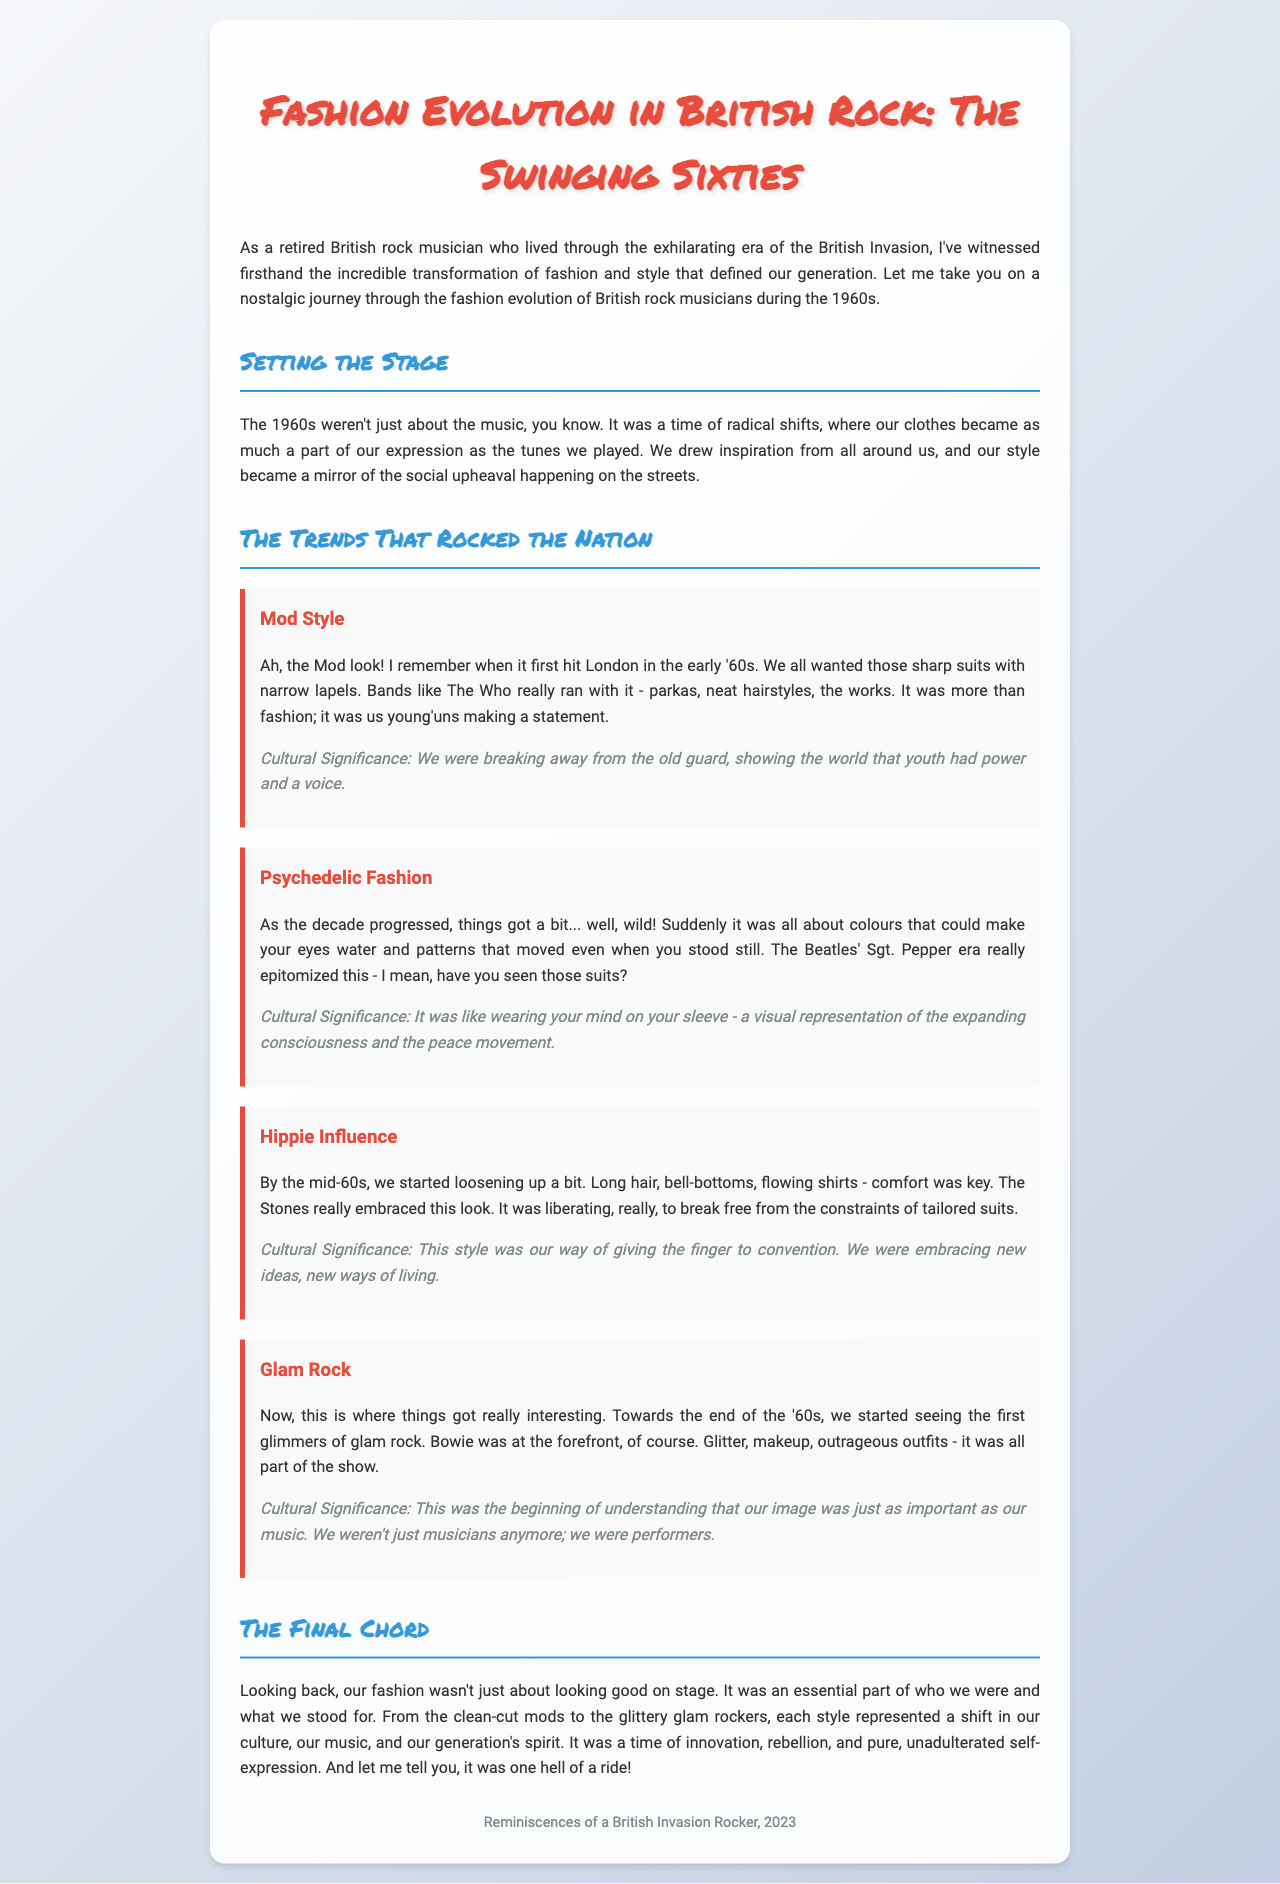what is the title of the document? The title is mentioned at the top of the document.
Answer: Fashion Evolution in British Rock: The Swinging Sixties who were the first to embrace Mod Style? The document mentions a specific band associated with the Mod style.
Answer: The Who what musical era is associated with psychedelic fashion? The document refers to a specific album for the psychedelic fashion trend.
Answer: Sgt. Pepper what new clothing items did rock musicians adopt by the mid-60s? The description of hippie influence includes specific clothing styles.
Answer: Bell-bottoms which rock artist is highlighted for glam rock? The document names a specific artist who led the glam rock movement.
Answer: Bowie what was a key quality of Mod Style according to the document? The document notes a significant attribute of Mod fashion.
Answer: Sharp suits what cultural movement does psychedelic fashion represent? The significance of psychedelic fashion is mentioned in relation to a broader movement.
Answer: Peace movement how did fashion reflect the social changes of the 1960s? The document explains the relationship between fashion and social context.
Answer: Mirror of social upheaval 